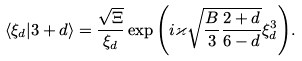Convert formula to latex. <formula><loc_0><loc_0><loc_500><loc_500>\langle \xi _ { d } | 3 + d \rangle = \frac { \sqrt { \Xi } } { \xi _ { d } } \exp { \left ( i \varkappa \sqrt { \frac { B } { 3 } \frac { 2 + d } { 6 - d } } \xi ^ { 3 } _ { d } \right ) } .</formula> 